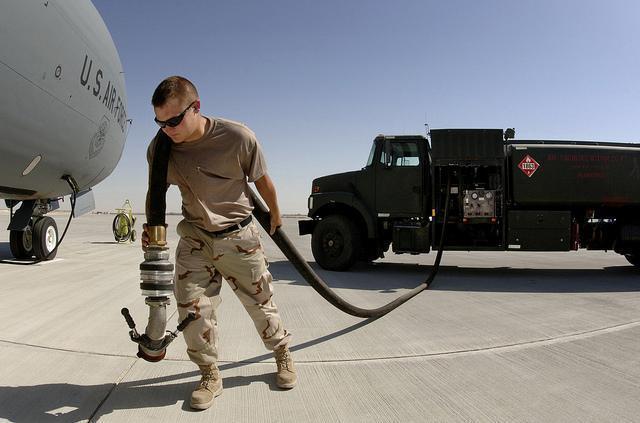How many airplanes are there?
Give a very brief answer. 1. 